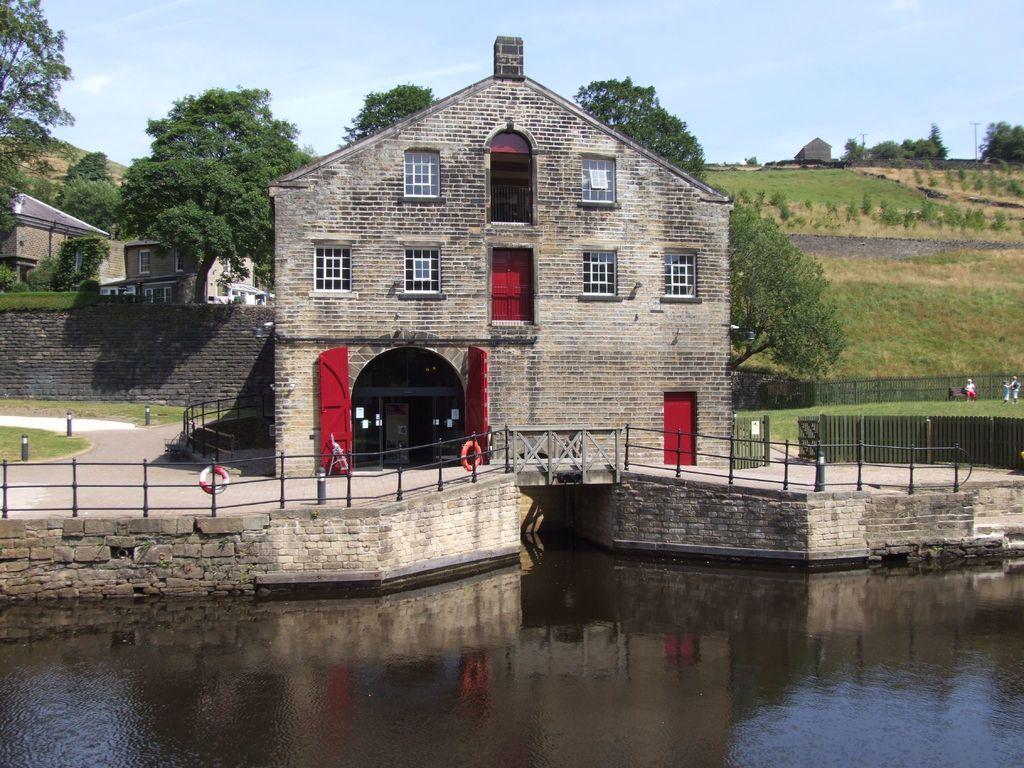In one or two sentences, can you explain what this image depicts? In this image we can see water at the bottom. Near to that there is a wall with railing. Also there is a building with windows and doors. Near to the building there are trees. Also there is a wall on the left side. And there is road. On the right side there are railings. And we can see few people. In the background there are trees, buildings and sky with clouds. 